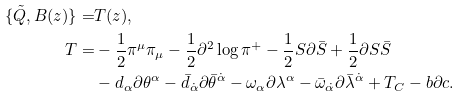Convert formula to latex. <formula><loc_0><loc_0><loc_500><loc_500>\{ \tilde { Q } , B ( z ) \} = & T ( z ) , \\ T = & - \frac { 1 } { 2 } \pi ^ { \mu } \pi _ { \mu } - \frac { 1 } { 2 } \partial ^ { 2 } \log \pi ^ { + } - \frac { 1 } { 2 } S \partial \bar { S } + \frac { 1 } { 2 } \partial S \bar { S } \\ & - d _ { \alpha } \partial \theta ^ { \alpha } - \bar { d } _ { \dot { \alpha } } \partial \bar { \theta } ^ { \dot { \alpha } } - \omega _ { \alpha } \partial \lambda ^ { \alpha } - \bar { \omega } _ { \dot { \alpha } } \partial \bar { \lambda } ^ { \dot { \alpha } } + T _ { C } - b \partial c .</formula> 